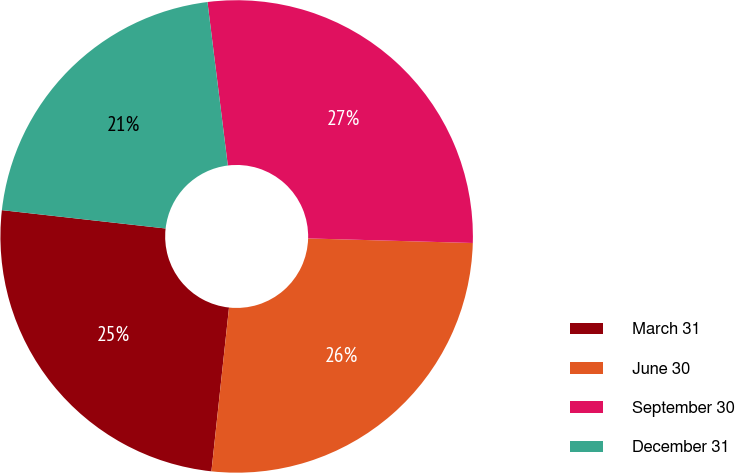Convert chart. <chart><loc_0><loc_0><loc_500><loc_500><pie_chart><fcel>March 31<fcel>June 30<fcel>September 30<fcel>December 31<nl><fcel>25.07%<fcel>26.26%<fcel>27.41%<fcel>21.25%<nl></chart> 